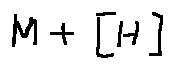Convert formula to latex. <formula><loc_0><loc_0><loc_500><loc_500>M + [ H ]</formula> 